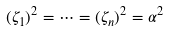Convert formula to latex. <formula><loc_0><loc_0><loc_500><loc_500>( \zeta _ { 1 } ) ^ { 2 } = \cdots = ( \zeta _ { n } ) ^ { 2 } = \alpha ^ { 2 }</formula> 